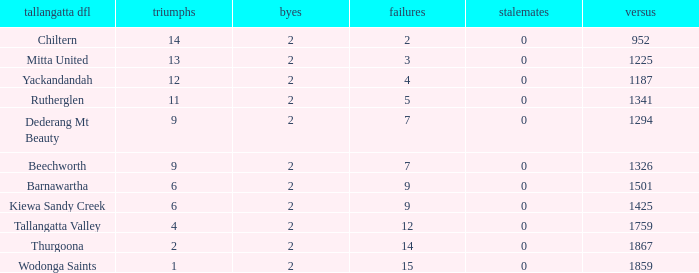What is the most byes with 11 wins and fewer than 1867 againsts? 2.0. 